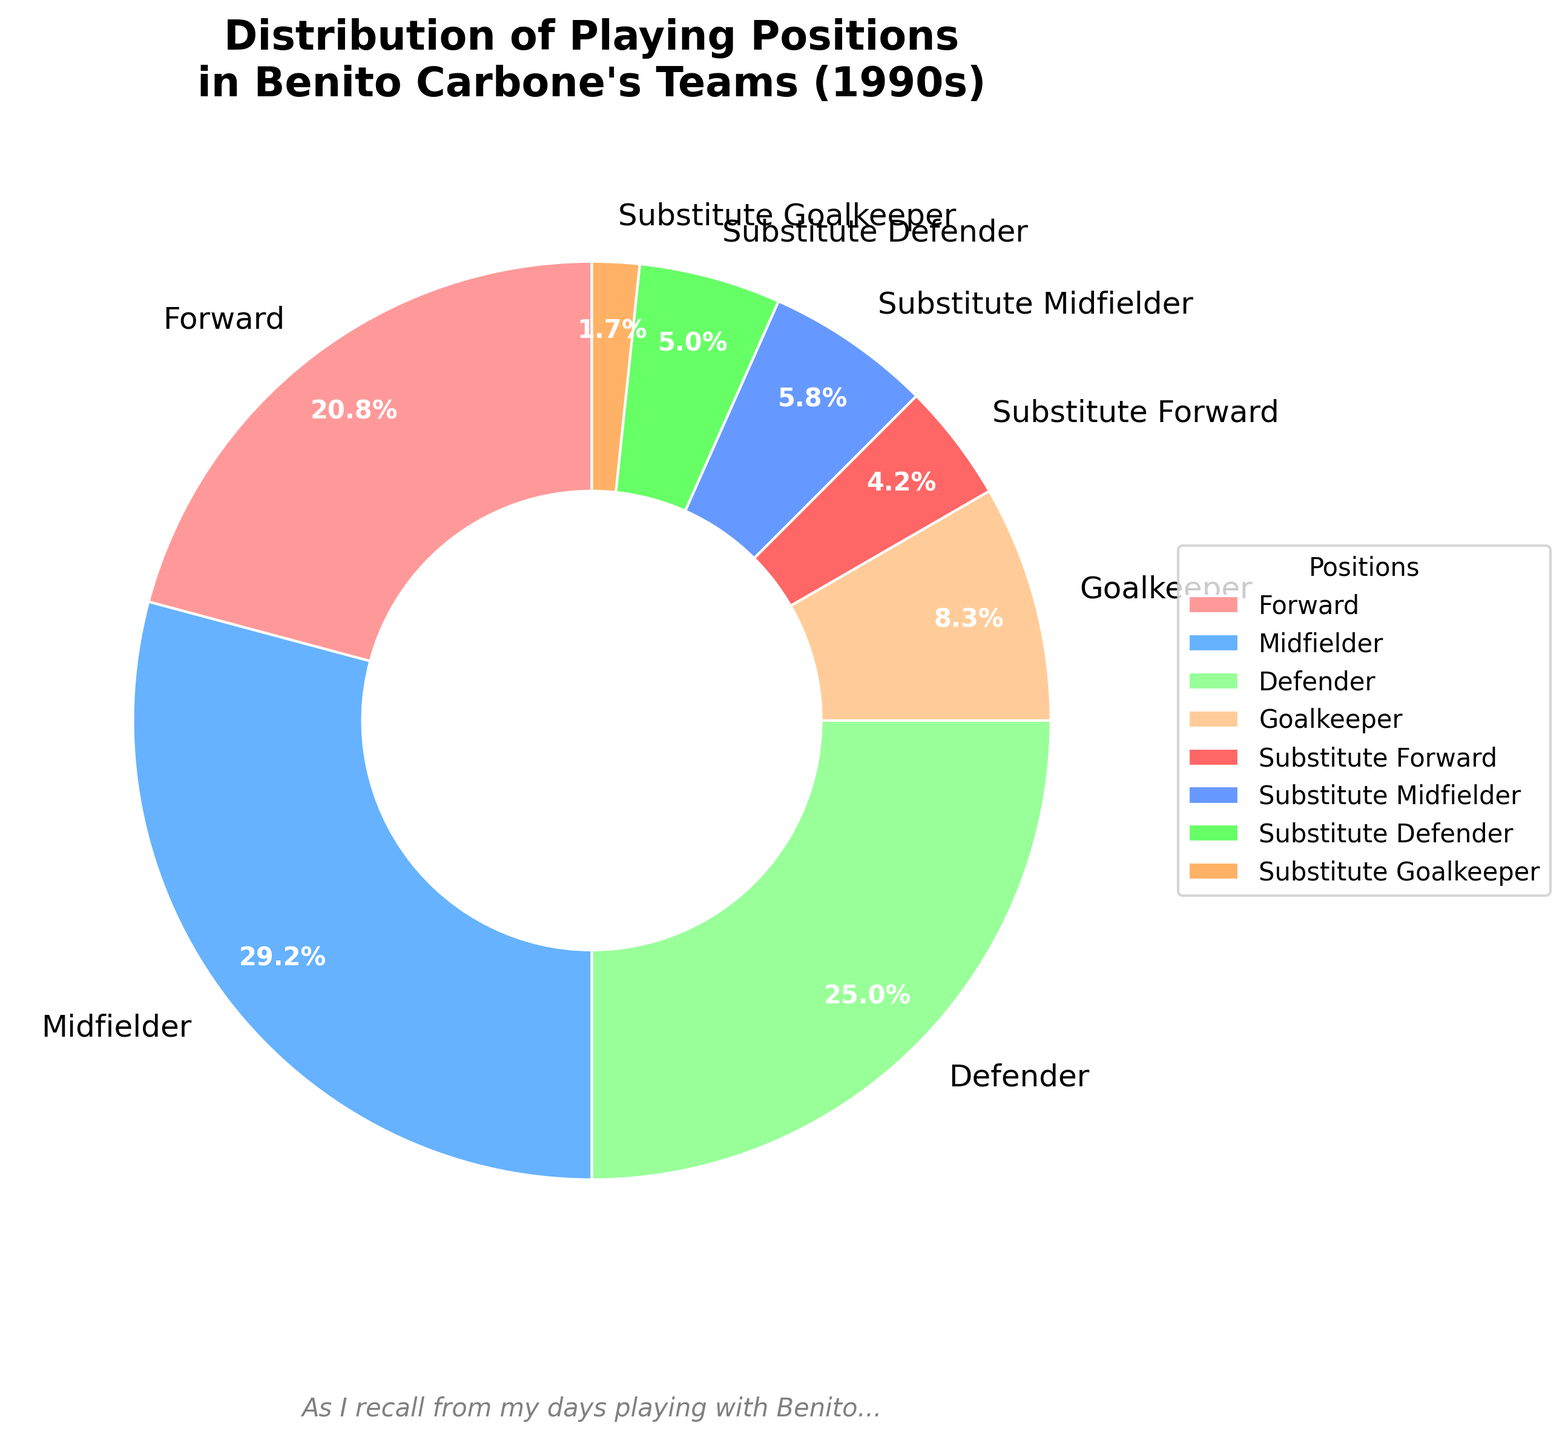Which position had the highest percentage in Benito Carbone's teams during the 1990s? The pie chart shows that Midfielders had the highest percentage, labeled as 35%.
Answer: Midfielder Which position, Forward or Defender, had a higher percentage, and by how much? Forwards had 25% while Defenders had 30%, so Defenders had 5% more.
Answer: Defender by 5% What's the combined percentage of all Substitute positions? Add the percentages of all substitute positions: Forward (5%), Midfielder (7%), Defender (6%), Goalkeeper (2%). Total: 5 + 7 + 6 + 2 = 20%.
Answer: 20% How does the percentage of Goalkeepers compare to Substitute Forwards? Goalkeepers' percentage is 10%, Substitute Forwards' is 5%, so Goalkeepers have 5% more.
Answer: Goalkeepers by 5% What is the ratio of Midfielders to Goalkeepers? Midfielders are 35%, and Goalkeepers are 10%. The ratio is 35:10, which simplifies to 7:2.
Answer: 7:2 Which color represents the Forward position in the pie chart? The color red is associated with Forwards in the pie chart.
Answer: Red Is the percentage of Defenders more than the sum of Substitute Midfielders and Substitute Goalkeepers? If yes, by how much? Defenders have 30%. Substitute Midfielders are 7%, and Substitute Goalkeepers are 2%. Sum: 7 + 2 = 9%. Yes, Defenders exceed this sum by 30 - 9 = 21%.
Answer: Yes, by 21% Which position occupies the smallest part of the pie chart? The smallest part of the pie chart is labeled as Substitute Goalkeeper with 2%.
Answer: Substitute Goalkeeper What's the difference between the percentages of Midfielders and the combination of all Substitute positions? Midfielders are 35%. Combined Substitutes: 20%. Difference: 35 - 20 = 15%.
Answer: 15% What are the two positions with the closest percentages, and what is their difference? Forwards (25%) and Defenders (30%) are closest. Difference: 30 - 25 = 5%.
Answer: Forward and Defender, 5% 